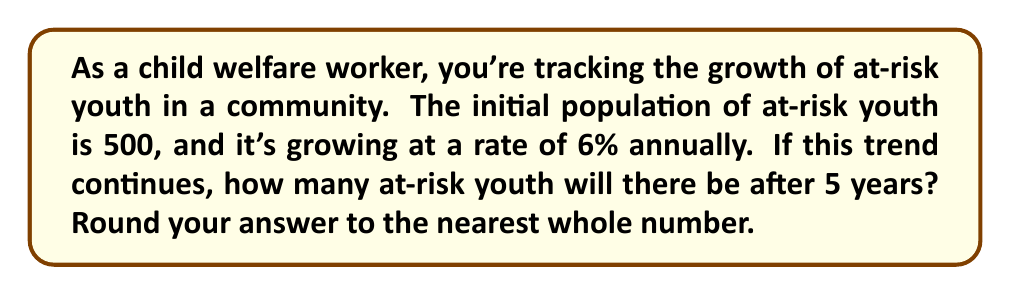What is the answer to this math problem? Let's approach this step-by-step using an exponential growth model:

1) The exponential growth formula is:
   $$A = P(1 + r)^t$$
   where:
   $A$ = final amount
   $P$ = initial principal (starting amount)
   $r$ = growth rate (as a decimal)
   $t$ = time period

2) We know:
   $P = 500$ (initial population)
   $r = 0.06$ (6% written as a decimal)
   $t = 5$ years

3) Let's substitute these values into our formula:
   $$A = 500(1 + 0.06)^5$$

4) Simplify inside the parentheses:
   $$A = 500(1.06)^5$$

5) Calculate $(1.06)^5$:
   $$A = 500 * 1.3382256$$

6) Multiply:
   $$A = 669.1128$$

7) Round to the nearest whole number:
   $$A ≈ 669$$

Therefore, after 5 years, there will be approximately 669 at-risk youth in the community.
Answer: 669 